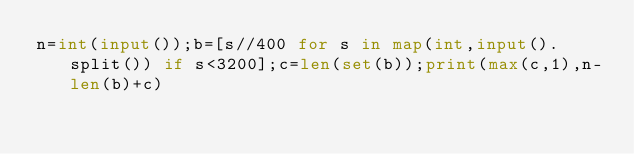<code> <loc_0><loc_0><loc_500><loc_500><_Python_>n=int(input());b=[s//400 for s in map(int,input().split()) if s<3200];c=len(set(b));print(max(c,1),n-len(b)+c)</code> 